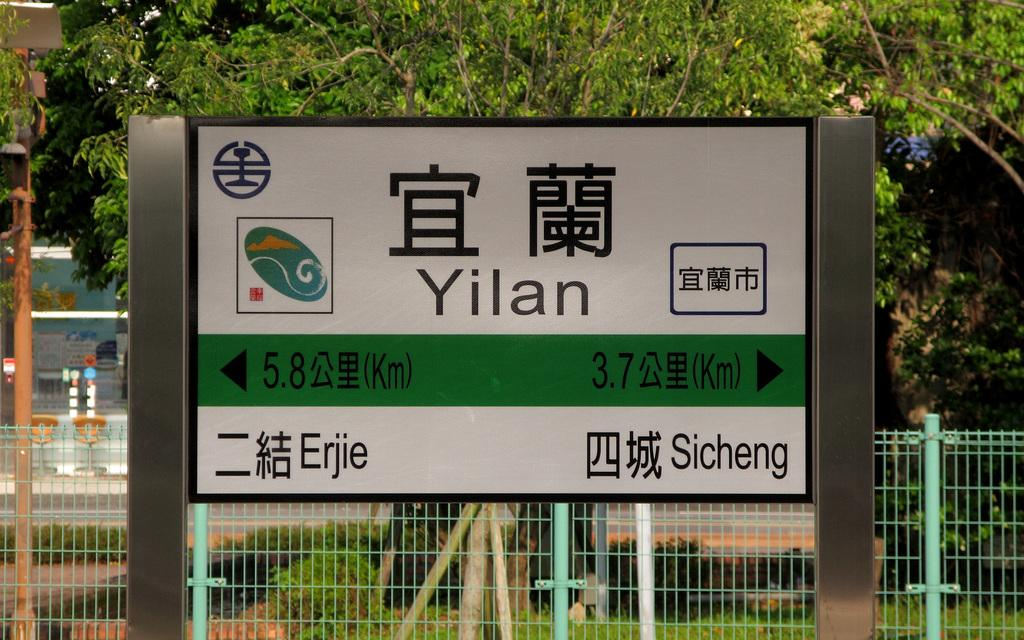What is the main object in the image? There is a board with directions in the image. What is located behind the board? There is a fence behind the board. What can be seen in the background of the image? There are trees in the background of the image. What type of glue is mentioned in the directions on the board? There is no mention of glue in the directions on the board. Can you see a tiger hiding behind the trees in the background? There is no tiger present in the image; it only features a board with directions, a fence, and trees in the background. 